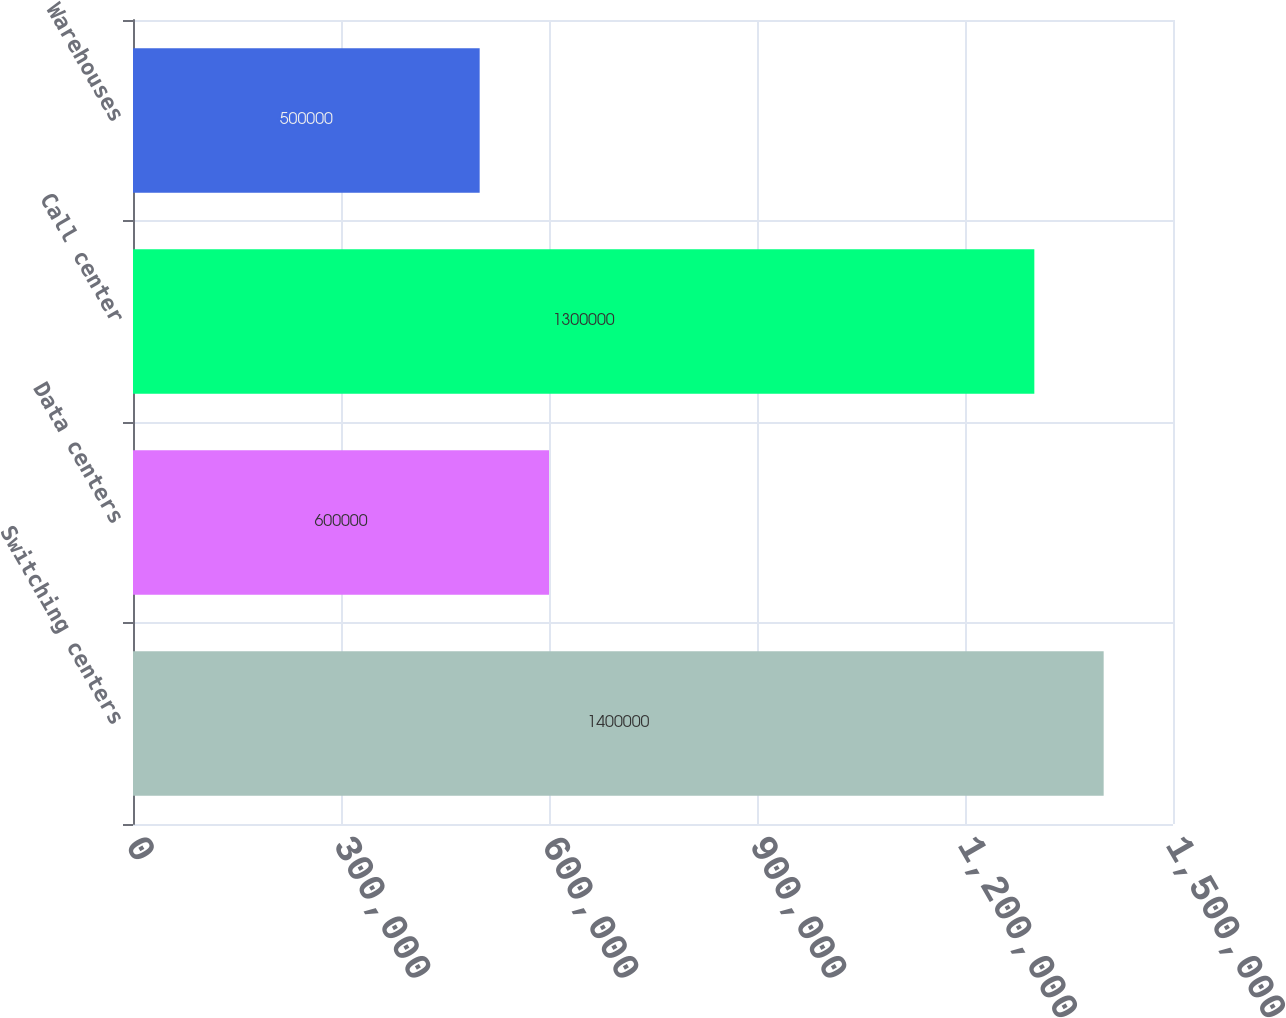<chart> <loc_0><loc_0><loc_500><loc_500><bar_chart><fcel>Switching centers<fcel>Data centers<fcel>Call center<fcel>Warehouses<nl><fcel>1.4e+06<fcel>600000<fcel>1.3e+06<fcel>500000<nl></chart> 